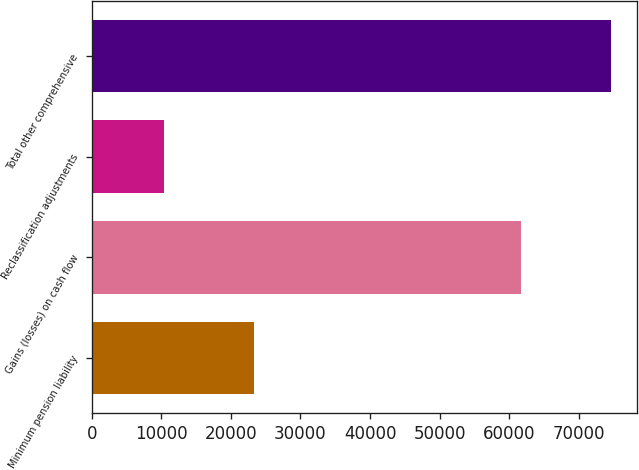<chart> <loc_0><loc_0><loc_500><loc_500><bar_chart><fcel>Minimum pension liability<fcel>Gains (losses) on cash flow<fcel>Reclassification adjustments<fcel>Total other comprehensive<nl><fcel>23362<fcel>61715<fcel>10386<fcel>74691<nl></chart> 